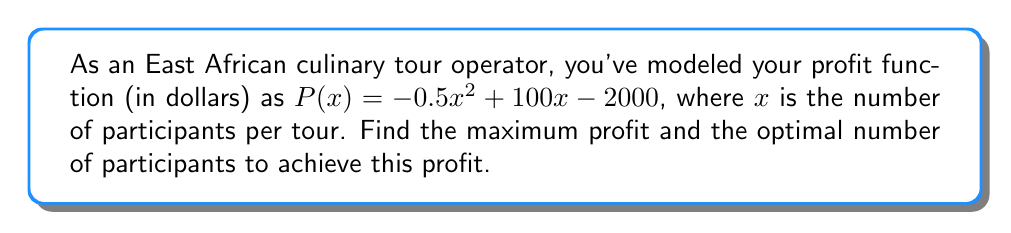Teach me how to tackle this problem. To find the maximum profit point, we need to follow these steps:

1) The profit function is a quadratic equation. Its graph is a parabola that opens downward (because the coefficient of $x^2$ is negative). The maximum point occurs at the vertex of this parabola.

2) To find the vertex, we can use the formula $x = -\frac{b}{2a}$, where $a$ and $b$ are the coefficients of $x^2$ and $x$ respectively in the quadratic equation $ax^2 + bx + c$.

3) In this case, $a = -0.5$ and $b = 100$. Let's substitute these values:

   $x = -\frac{100}{2(-0.5)} = -\frac{100}{-1} = 100$

4) This means the optimal number of participants is 100.

5) To find the maximum profit, we substitute $x = 100$ into the original profit function:

   $P(100) = -0.5(100)^2 + 100(100) - 2000$
           $= -5000 + 10000 - 2000$
           $= 3000$

Therefore, the maximum profit is $3000.
Answer: Maximum profit: $3000; Optimal number of participants: 100 